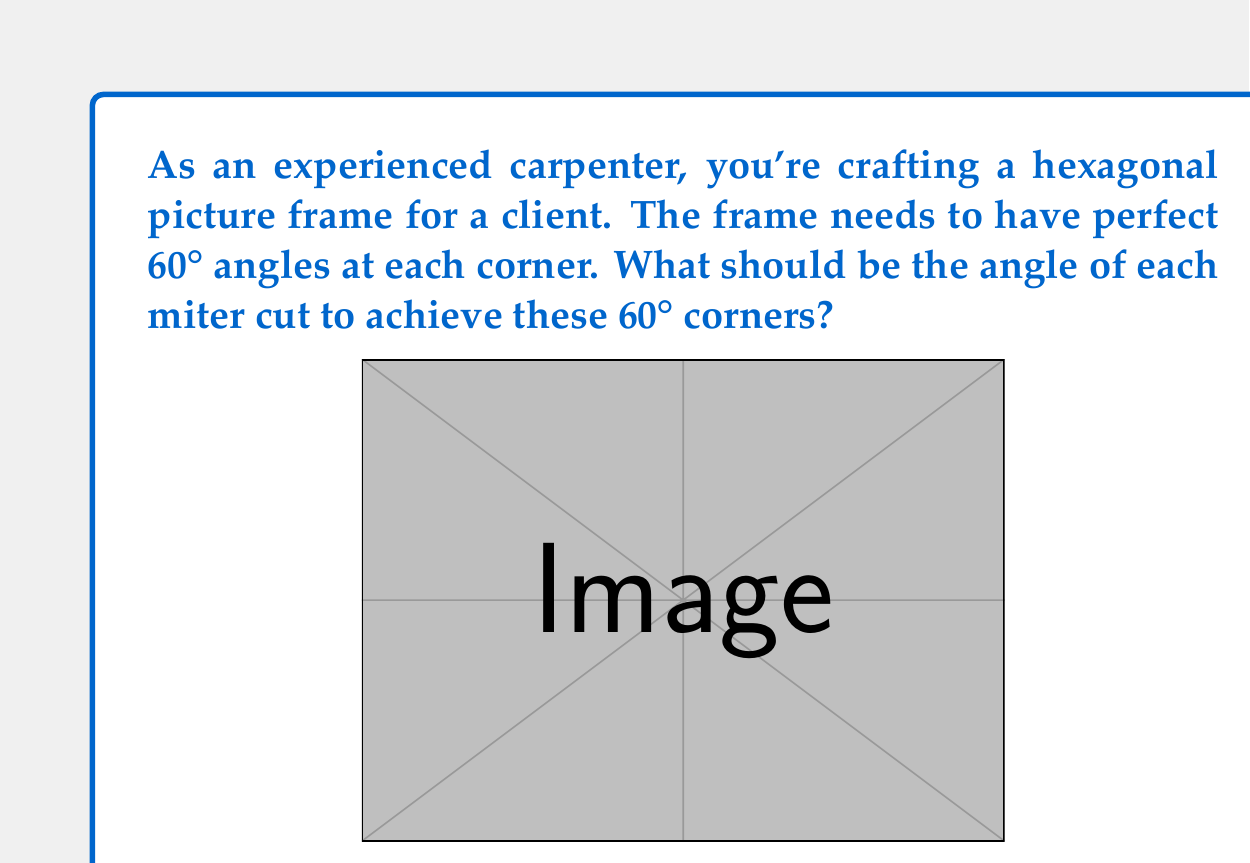Give your solution to this math problem. To solve this problem, let's break it down step-by-step:

1) In a hexagon, each interior angle is 120°. This is because the sum of interior angles of a hexagon is $(n-2) \times 180°$, where $n$ is the number of sides. For a hexagon, this is $(6-2) \times 180° = 720°$. Divided by 6, we get 120° for each interior angle.

2) The frame corners, however, need to be 60°. This is the supplement of the 120° interior angle (120° + 60° = 180°).

3) For a miter joint, we need to cut each piece at half the angle we want to create. This is because two pieces will come together to form the joint.

4) Let $\theta$ be the angle of each miter cut. We can set up the equation:

   $$2\theta = 180° - 60°$$

   This is because the two miter cuts (2$\theta$) plus the desired 60° corner should sum to 180°.

5) Solving for $\theta$:

   $$2\theta = 120°$$
   $$\theta = 60°$$

Therefore, each miter cut should be at a 60° angle to create a 60° corner when two pieces are joined.
Answer: The angle for each miter cut should be $60°$. 